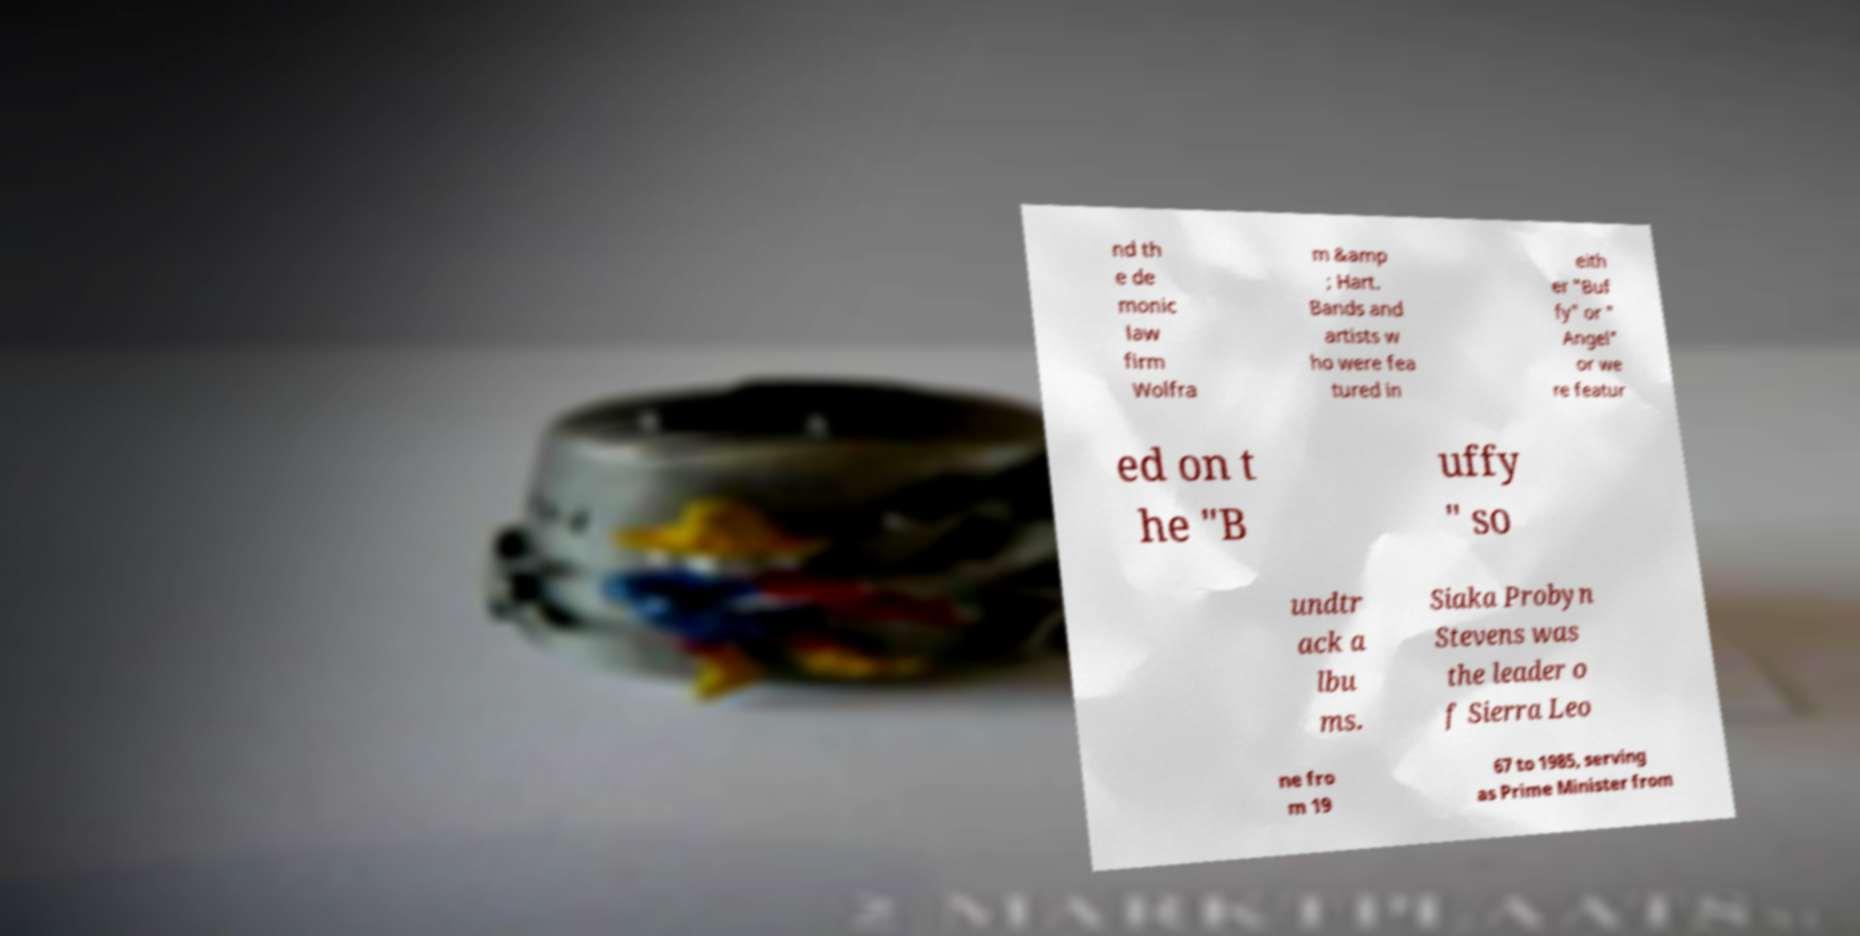Can you accurately transcribe the text from the provided image for me? nd th e de monic law firm Wolfra m &amp ; Hart. Bands and artists w ho were fea tured in eith er "Buf fy" or " Angel" or we re featur ed on t he "B uffy " so undtr ack a lbu ms. Siaka Probyn Stevens was the leader o f Sierra Leo ne fro m 19 67 to 1985, serving as Prime Minister from 